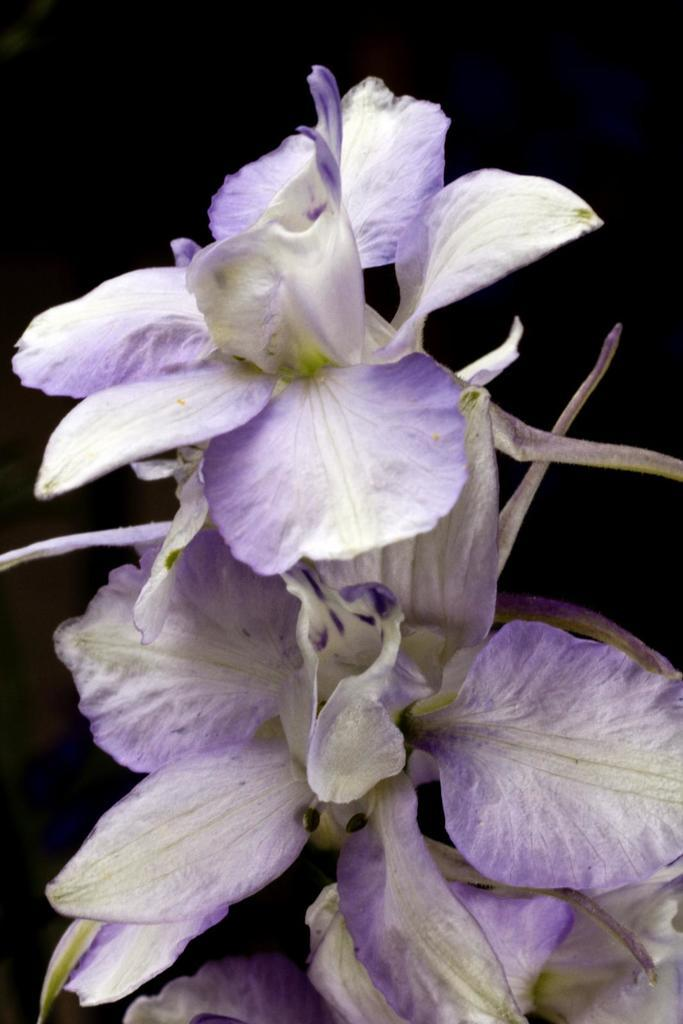What is the main subject of the image? There is a flower in the image. What color is the background of the image? The background of the image is black in color. What type of theory is being discussed in the image? There is no discussion or theory present in the image; it features a flower against a black background. Can you see a drum in the image? There is no drum present in the image. 